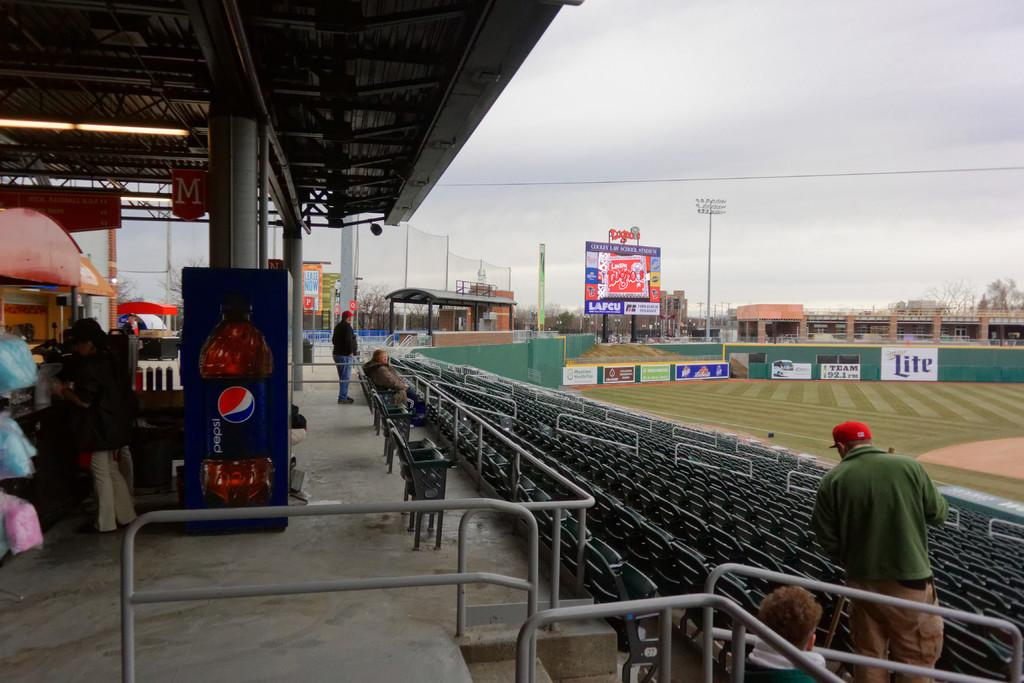<image>
Relay a brief, clear account of the picture shown. a field with a sign on it that says 'miller lite' 